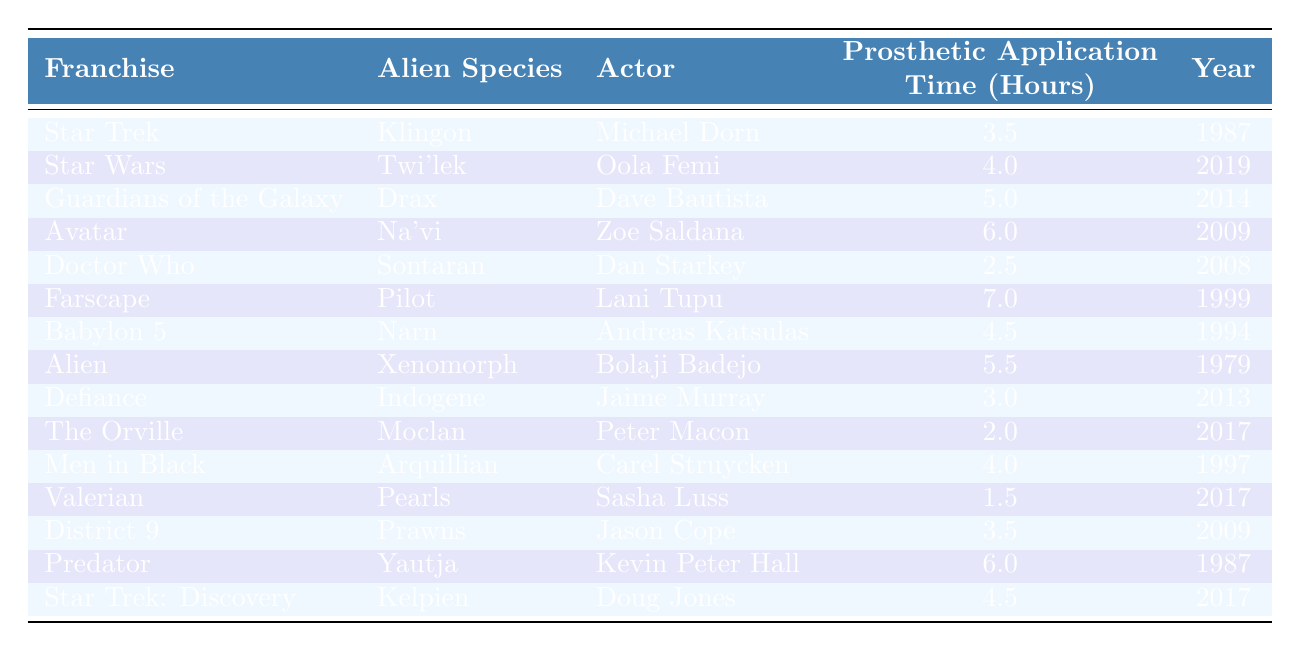What is the maximum time spent on prosthetic application for a single alien species? Reviewing the data, the maximum is the highest figure in the "Prosthetic Application Time" column, which is 7 hours for the alien species Pilot in the franchise Farscape.
Answer: 7 hours Which alien species had the longest prosthetic application time? By examining the table, the longeset time listed is for Farscape's Pilot at 7 hours, making this the species with the longest application duration.
Answer: Pilot How many hours did it take to apply the prosthetic makeup for the Twi'lek character? The Twi'lek character's makeup application took 4 hours, which is directly stated in the table under "Prosthetic Application Time" for that species.
Answer: 4 hours Was the prosthetic application time for the Indogene character less than 4 hours? The application time for Indogene is shown as 3 hours, which is indeed less than 4 hours.
Answer: Yes What is the average prosthetic application time for these alien species? To find the average, sum all the prosthetic application times (3.5 + 4 + 5 + 6 + 2.5 + 7 + 4.5 + 5.5 + 3 + 2 + 4 + 1.5 + 3.5 + 6 + 4.5) which equals 57.5 hours. There are 15 data points. Now, divide the total (57.5) by the number of entries (15), resulting in an average of 3.83 hours.
Answer: 3.83 hours Which actor required the least time for prosthetic application? The actor that required the least application time is Sasha Luss for the Pearls character in Valerian, with only 1.5 hours of application time, as listed in the table.
Answer: Sasha Luss What can be said about the prosthetic application time for the Na'vi species compared to the Xenomorph? The table shows 6 hours for the Na'vi and 5.5 hours for the Xenomorph, meaning the Na'vi required more time for prosthetic application than the Xenomorph.
Answer: Na'vi required more time Did any actor from the Star Trek franchise have a higher prosthetic makeup application time than the actor from Predator? Michael Dorn from Star Trek spent 3.5 hours, while Kevin Peter Hall from Predator spent 6 hours. Since 6 is greater than 3.5, Michael Dorn's time was not higher.
Answer: No What is the difference in prosthetic application time between the Moclan and Prawns species? The Moclan required 2 hours and the Prawns required 3.5 hours. The difference is calculated by subtracting 2 from 3.5, resulting in 1.5 hours more for the Prawns.
Answer: 1.5 hours Which actor performed prosthetic application for the Drax character, and how long did it take? The Drax character was portrayed by Dave Bautista, who required 5 hours for prosthetic application, as shown in the table.
Answer: Dave Bautista, 5 hours How many alien species had a prosthetic application time of 4.5 hours or more? The species with 4.5 hours or more are: Drax, Na'vi, Farscape's Pilot, Xenomorph, Predator, and Kelpien. Counting these, there are 6 species that fit this criterion.
Answer: 6 